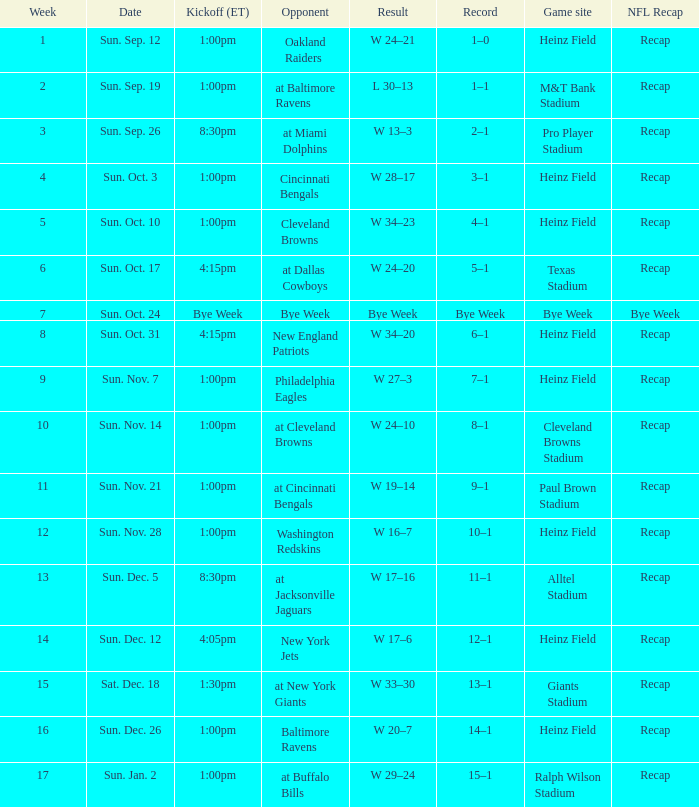Which Opponent has a Game site of heinz field, and a Record of 3–1? Cincinnati Bengals. 